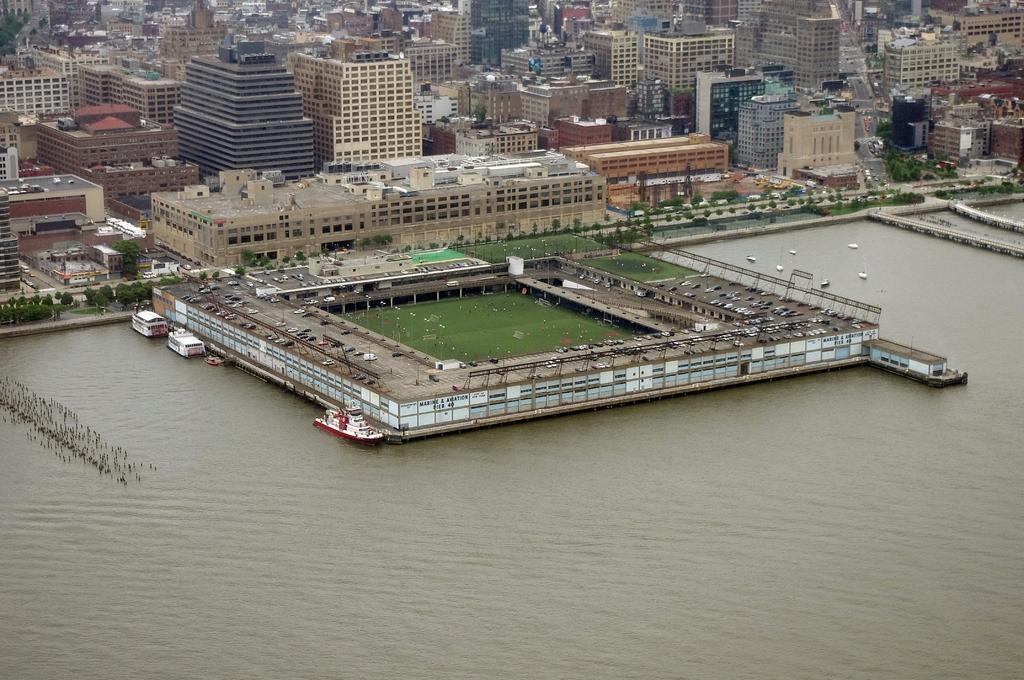Could you give a brief overview of what you see in this image? In this image there is water, and there is some boats sailing on the water, in the background of the image there is a stadium and there are buildings and trees. 